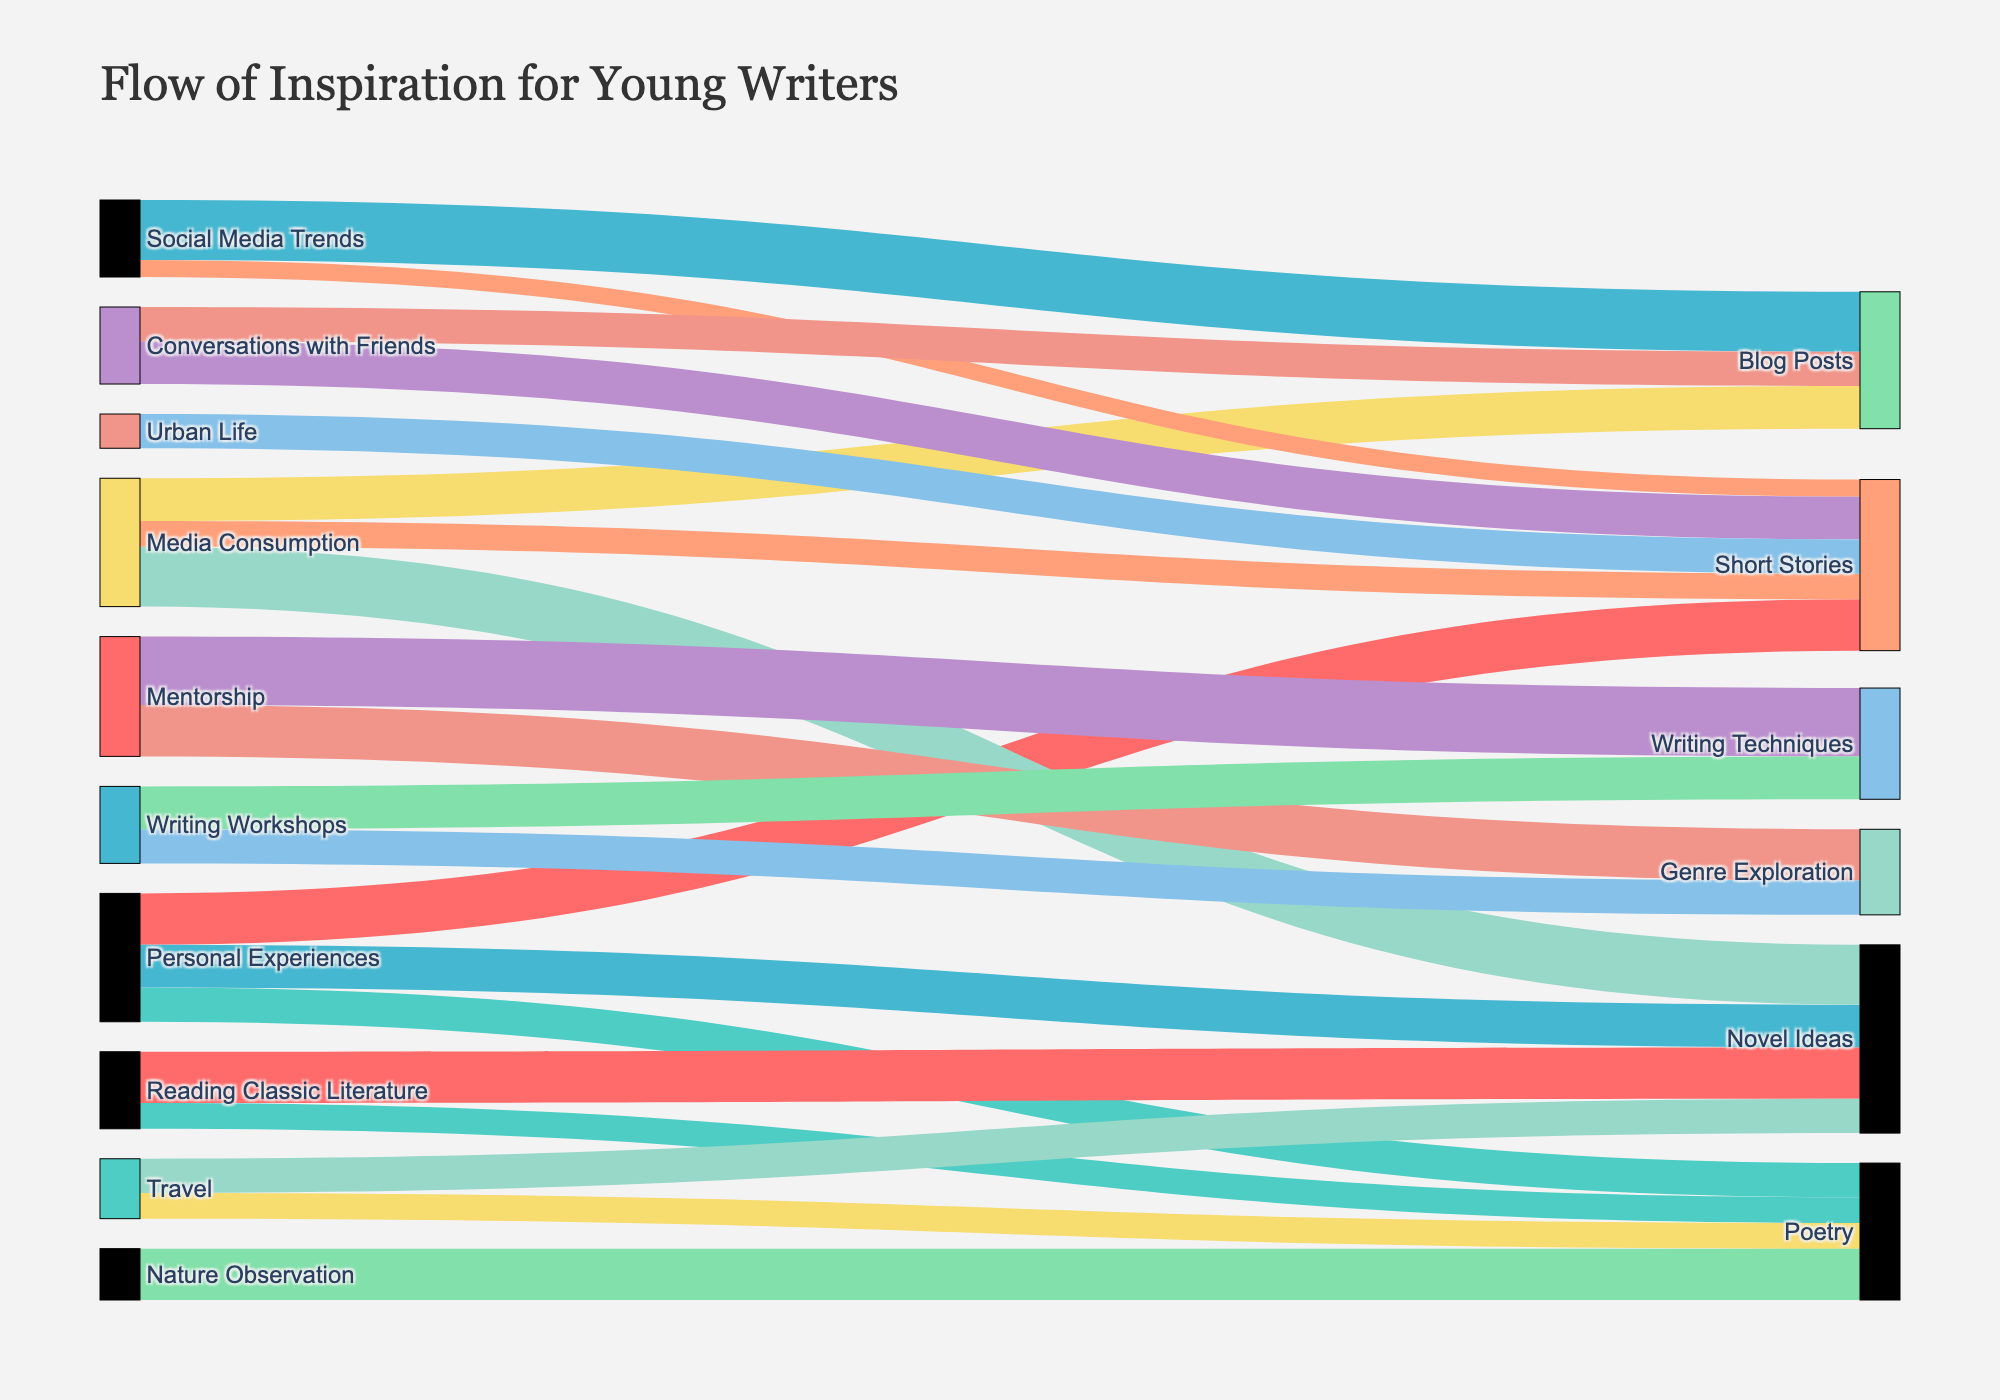What is the title of the Sankey Diagram? The title is usually positioned at the top of the figure, and it helps in understanding the general theme or subject of the visualization. In this case, the title is displayed prominently in the layout settings.
Answer: Flow of Inspiration for Young Writers Which source contributes the most to "Short Stories"? By examining the thickness of the links connecting different sources to "Short Stories," we can identify the one with the greatest value. The values are shown next to the links.
Answer: Personal Experiences What is the combined contribution of "Travel" and "Nature Observation" to "Poetry"? We need to add up the values connecting "Travel" and "Nature Observation" to "Poetry." From the data, "Travel" contributes 15 and "Nature Observation" contributes 30, so their combined contribution is 15 + 30 = 45.
Answer: 45 Which target has the highest absolute value from a single source? We look for the thickest link from any source to a target. "Mentorship" contributing 40 to "Writing Techniques" appears the largest.
Answer: Writing Techniques (40) How does the contribution of "Conversations with Friends" to "Blog Posts" compare to that of "Social Media Trends" to "Blog Posts"? By comparing the link thickness and values, "Conversations with Friends" contributes 20, while "Social Media Trends" contributes 35 to "Blog Posts."
Answer: Social Media Trends > Conversations with Friends What is the total contribution of "Media Consumption" across all targets? Summing up the values associated with "Media Consumption" to all its targets: Short Stories (15), Novel Ideas (35), and Blog Posts (25). 15 + 35 + 25 = 75.
Answer: 75 Which source influences "Poetry" the most? By examining the connection values to "Poetry," "Personal Experiences" has 20, "Travel" has 15, and "Reading Classic Literature" has 15. "Nature Observation" has the highest with 30.
Answer: Nature Observation What are the sources that contribute to "Novel Ideas"? Examining the diagram, the sources linking to "Novel Ideas" include "Personal Experiences" (25), "Media Consumption" (35), "Reading Classic Literature" (30), and "Travel" (20).
Answer: Personal Experiences, Media Consumption, Reading Classic Literature, Travel Which source has the smallest influence on "Short Stories"? We compare the values linked to "Short Stories": "Media Consumption" (15), "Urban Life" (20), "Conversations with Friends" (25), and "Social Media Trends" (10). "Social Media Trends" has the smallest value.
Answer: Social Media Trends What is the overall contribution of "Mentorship" and "Writing Workshops" to "Writing Techniques"? We sum the values from "Mentorship" (40) and "Writing Workshops" (25) to "Writing Techniques." 40 + 25 = 65.
Answer: 65 